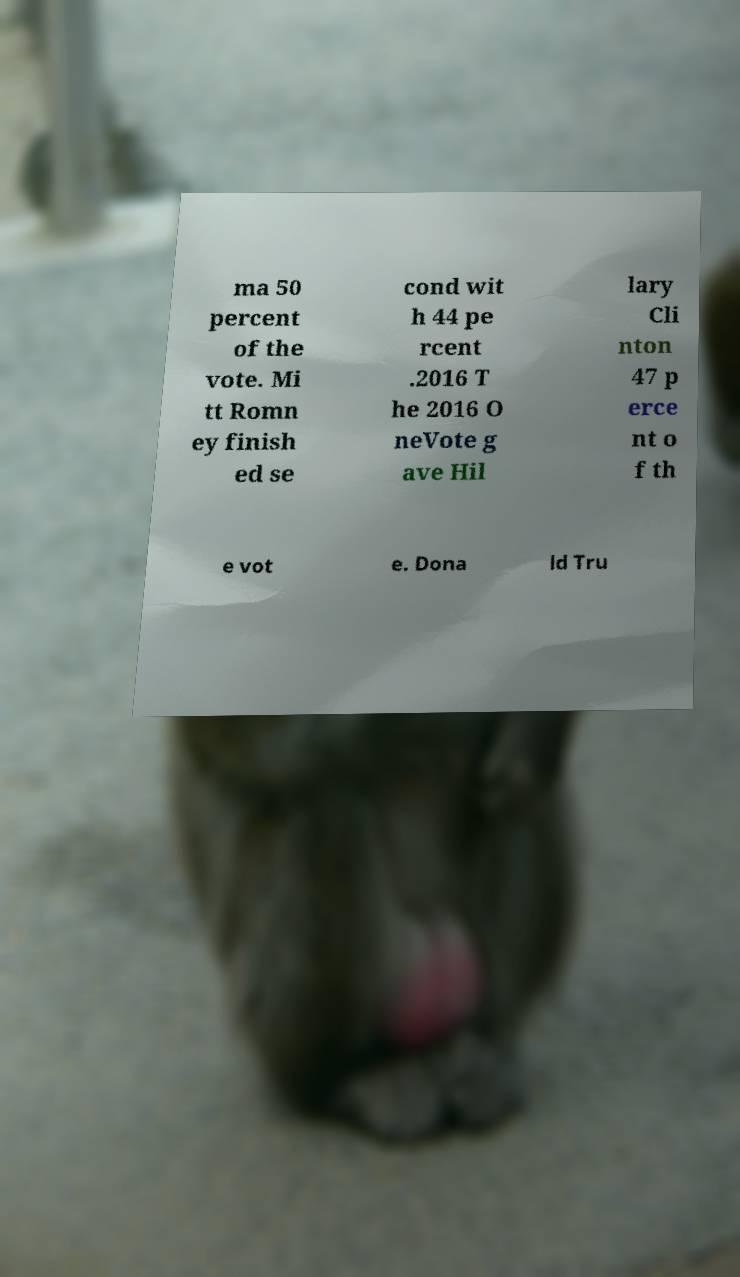Can you read and provide the text displayed in the image?This photo seems to have some interesting text. Can you extract and type it out for me? ma 50 percent of the vote. Mi tt Romn ey finish ed se cond wit h 44 pe rcent .2016 T he 2016 O neVote g ave Hil lary Cli nton 47 p erce nt o f th e vot e. Dona ld Tru 